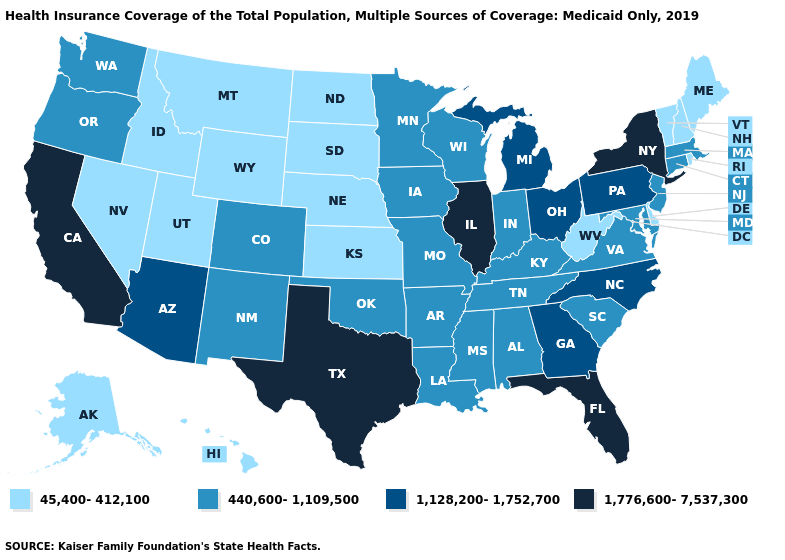Among the states that border Maryland , which have the lowest value?
Be succinct. Delaware, West Virginia. What is the value of Texas?
Keep it brief. 1,776,600-7,537,300. Which states have the lowest value in the MidWest?
Keep it brief. Kansas, Nebraska, North Dakota, South Dakota. Name the states that have a value in the range 440,600-1,109,500?
Be succinct. Alabama, Arkansas, Colorado, Connecticut, Indiana, Iowa, Kentucky, Louisiana, Maryland, Massachusetts, Minnesota, Mississippi, Missouri, New Jersey, New Mexico, Oklahoma, Oregon, South Carolina, Tennessee, Virginia, Washington, Wisconsin. What is the value of Wisconsin?
Short answer required. 440,600-1,109,500. What is the lowest value in the USA?
Give a very brief answer. 45,400-412,100. What is the value of Pennsylvania?
Write a very short answer. 1,128,200-1,752,700. Is the legend a continuous bar?
Concise answer only. No. What is the lowest value in the MidWest?
Be succinct. 45,400-412,100. Name the states that have a value in the range 45,400-412,100?
Give a very brief answer. Alaska, Delaware, Hawaii, Idaho, Kansas, Maine, Montana, Nebraska, Nevada, New Hampshire, North Dakota, Rhode Island, South Dakota, Utah, Vermont, West Virginia, Wyoming. Among the states that border New Jersey , does New York have the highest value?
Write a very short answer. Yes. What is the value of Wisconsin?
Answer briefly. 440,600-1,109,500. Among the states that border Kansas , which have the lowest value?
Short answer required. Nebraska. Does California have the highest value in the USA?
Concise answer only. Yes. Which states have the highest value in the USA?
Concise answer only. California, Florida, Illinois, New York, Texas. 